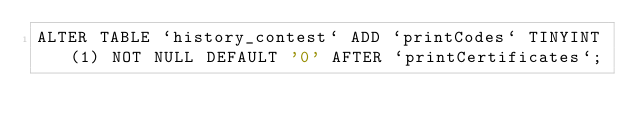<code> <loc_0><loc_0><loc_500><loc_500><_SQL_>ALTER TABLE `history_contest` ADD `printCodes` TINYINT(1) NOT NULL DEFAULT '0' AFTER `printCertificates`;</code> 